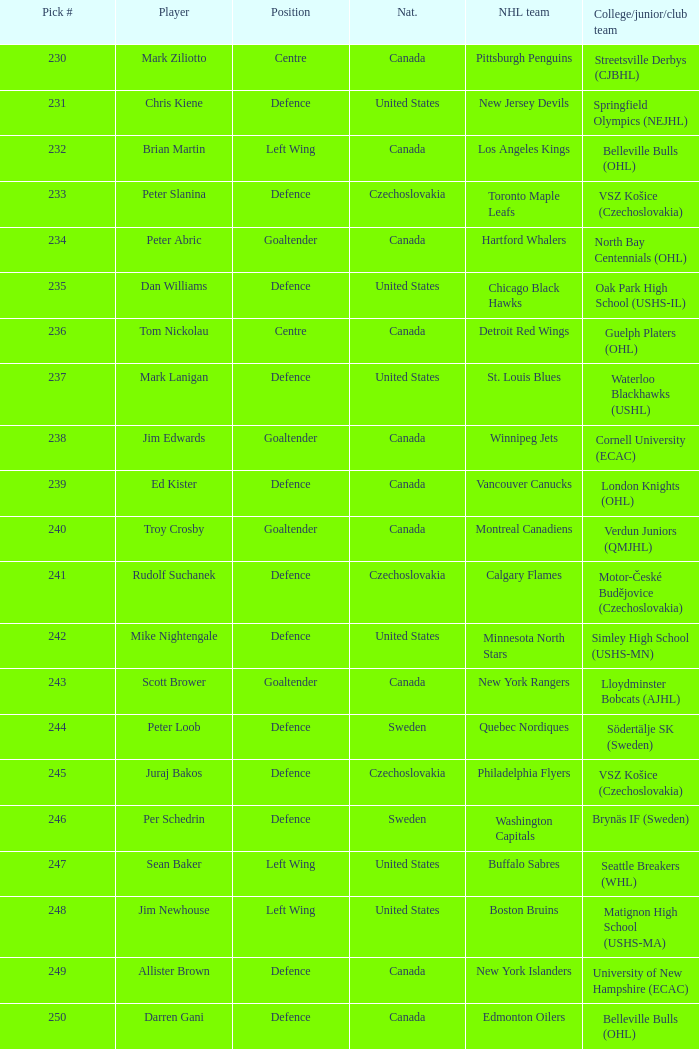What position does allister brown play. Defence. 